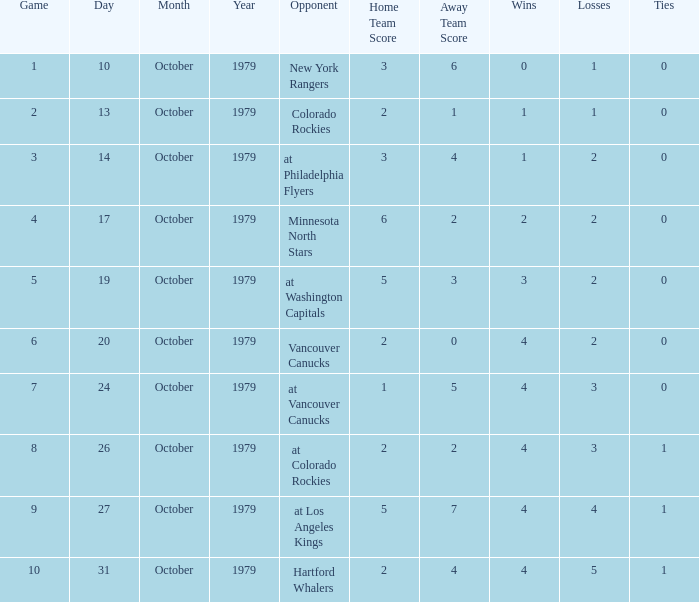What date is the record 4-3-0? 10/24/1979. 